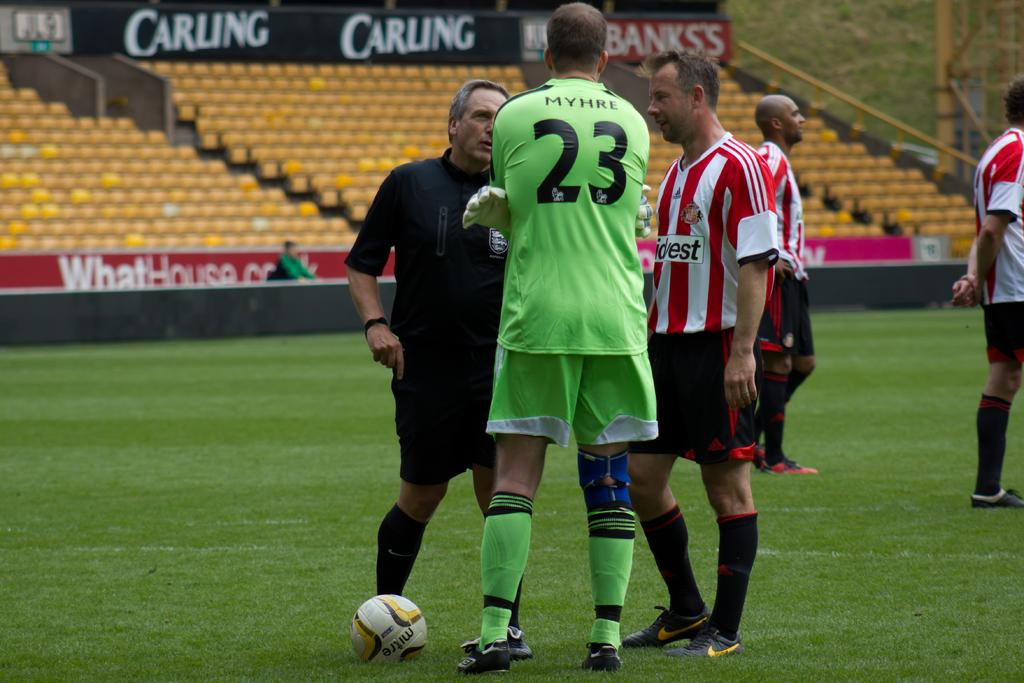<image>
Create a compact narrative representing the image presented. A group of men on a soccer field on in green with the number 23 on the jersey. 